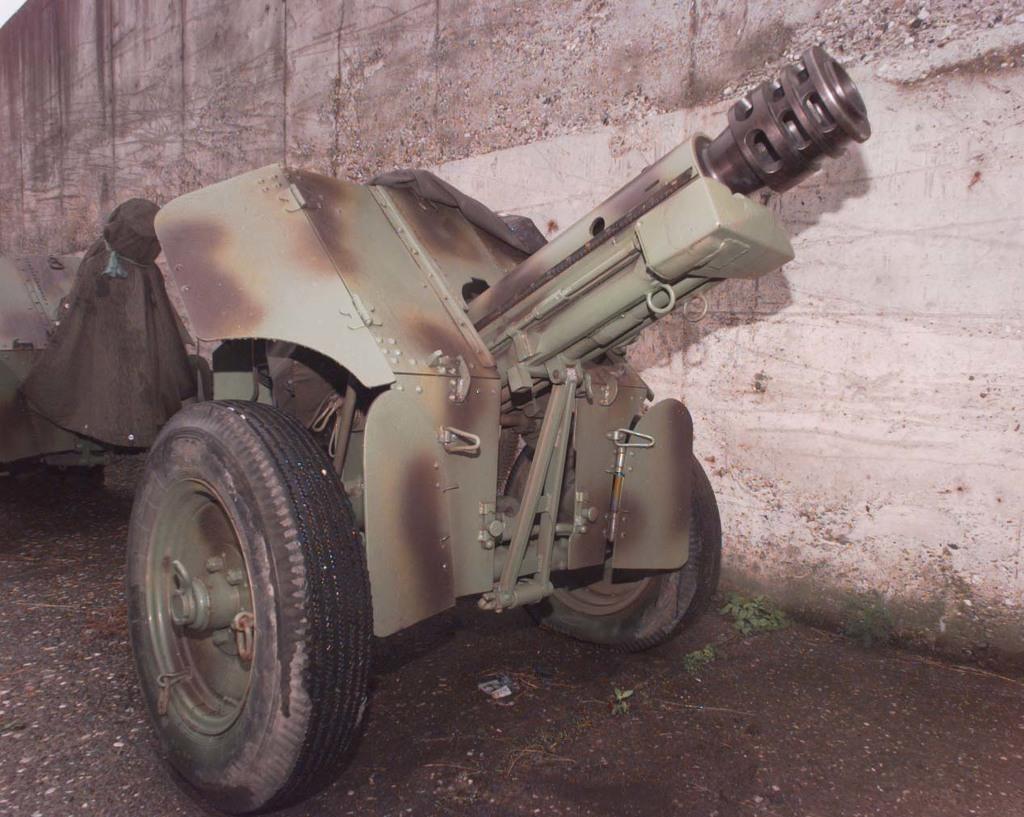Can you describe this image briefly? In the picture we can see a weapon vehicle with two wheels on the path and beside it we can see the wall. 